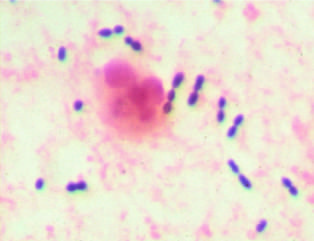what stain preparation of sputum from a patient with pneumonia?
Answer the question using a single word or phrase. Gram 